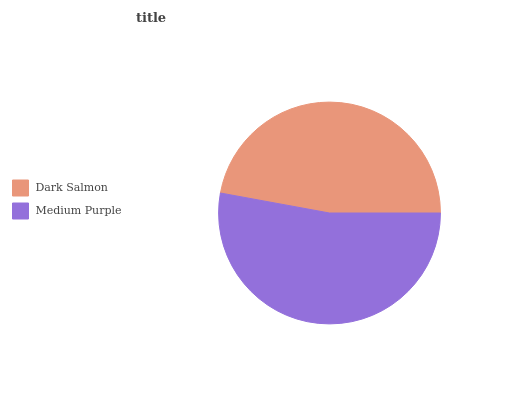Is Dark Salmon the minimum?
Answer yes or no. Yes. Is Medium Purple the maximum?
Answer yes or no. Yes. Is Medium Purple the minimum?
Answer yes or no. No. Is Medium Purple greater than Dark Salmon?
Answer yes or no. Yes. Is Dark Salmon less than Medium Purple?
Answer yes or no. Yes. Is Dark Salmon greater than Medium Purple?
Answer yes or no. No. Is Medium Purple less than Dark Salmon?
Answer yes or no. No. Is Medium Purple the high median?
Answer yes or no. Yes. Is Dark Salmon the low median?
Answer yes or no. Yes. Is Dark Salmon the high median?
Answer yes or no. No. Is Medium Purple the low median?
Answer yes or no. No. 